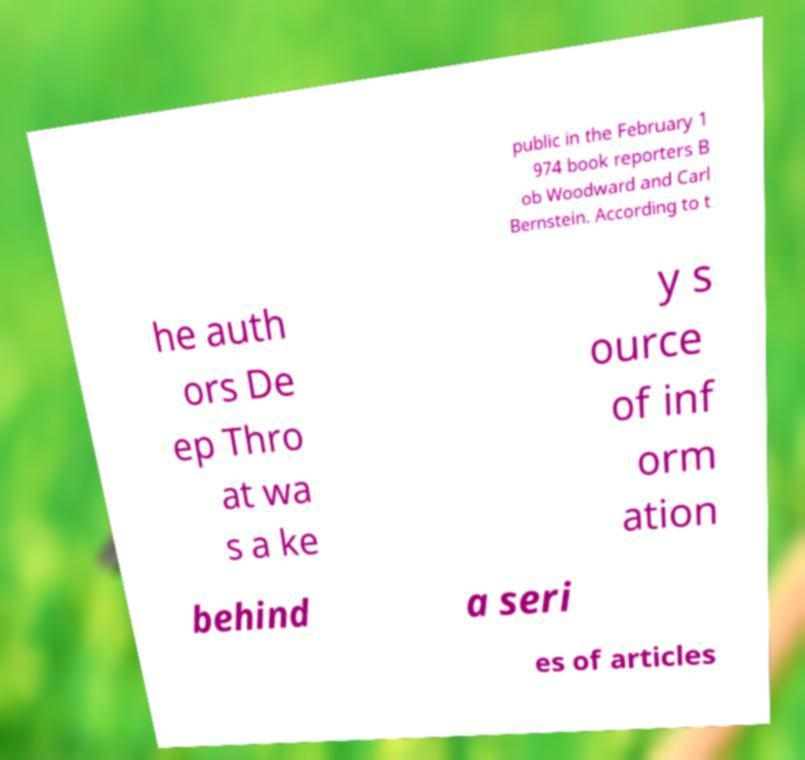There's text embedded in this image that I need extracted. Can you transcribe it verbatim? public in the February 1 974 book reporters B ob Woodward and Carl Bernstein. According to t he auth ors De ep Thro at wa s a ke y s ource of inf orm ation behind a seri es of articles 